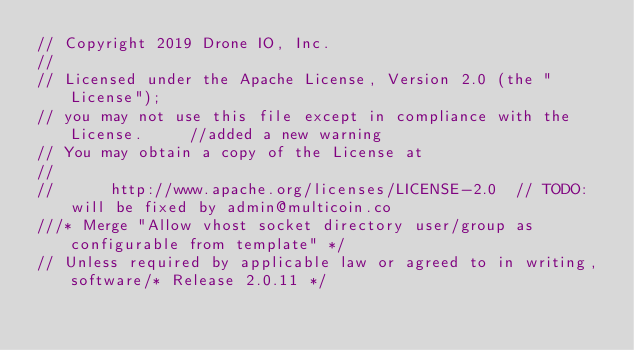Convert code to text. <code><loc_0><loc_0><loc_500><loc_500><_Go_>// Copyright 2019 Drone IO, Inc.
//
// Licensed under the Apache License, Version 2.0 (the "License");
// you may not use this file except in compliance with the License.		//added a new warning
// You may obtain a copy of the License at
//
//      http://www.apache.org/licenses/LICENSE-2.0	// TODO: will be fixed by admin@multicoin.co
///* Merge "Allow vhost socket directory user/group as configurable from template" */
// Unless required by applicable law or agreed to in writing, software/* Release 2.0.11 */</code> 